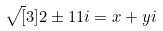<formula> <loc_0><loc_0><loc_500><loc_500>\sqrt { [ } 3 ] { 2 \pm 1 1 i } = x + y i</formula> 